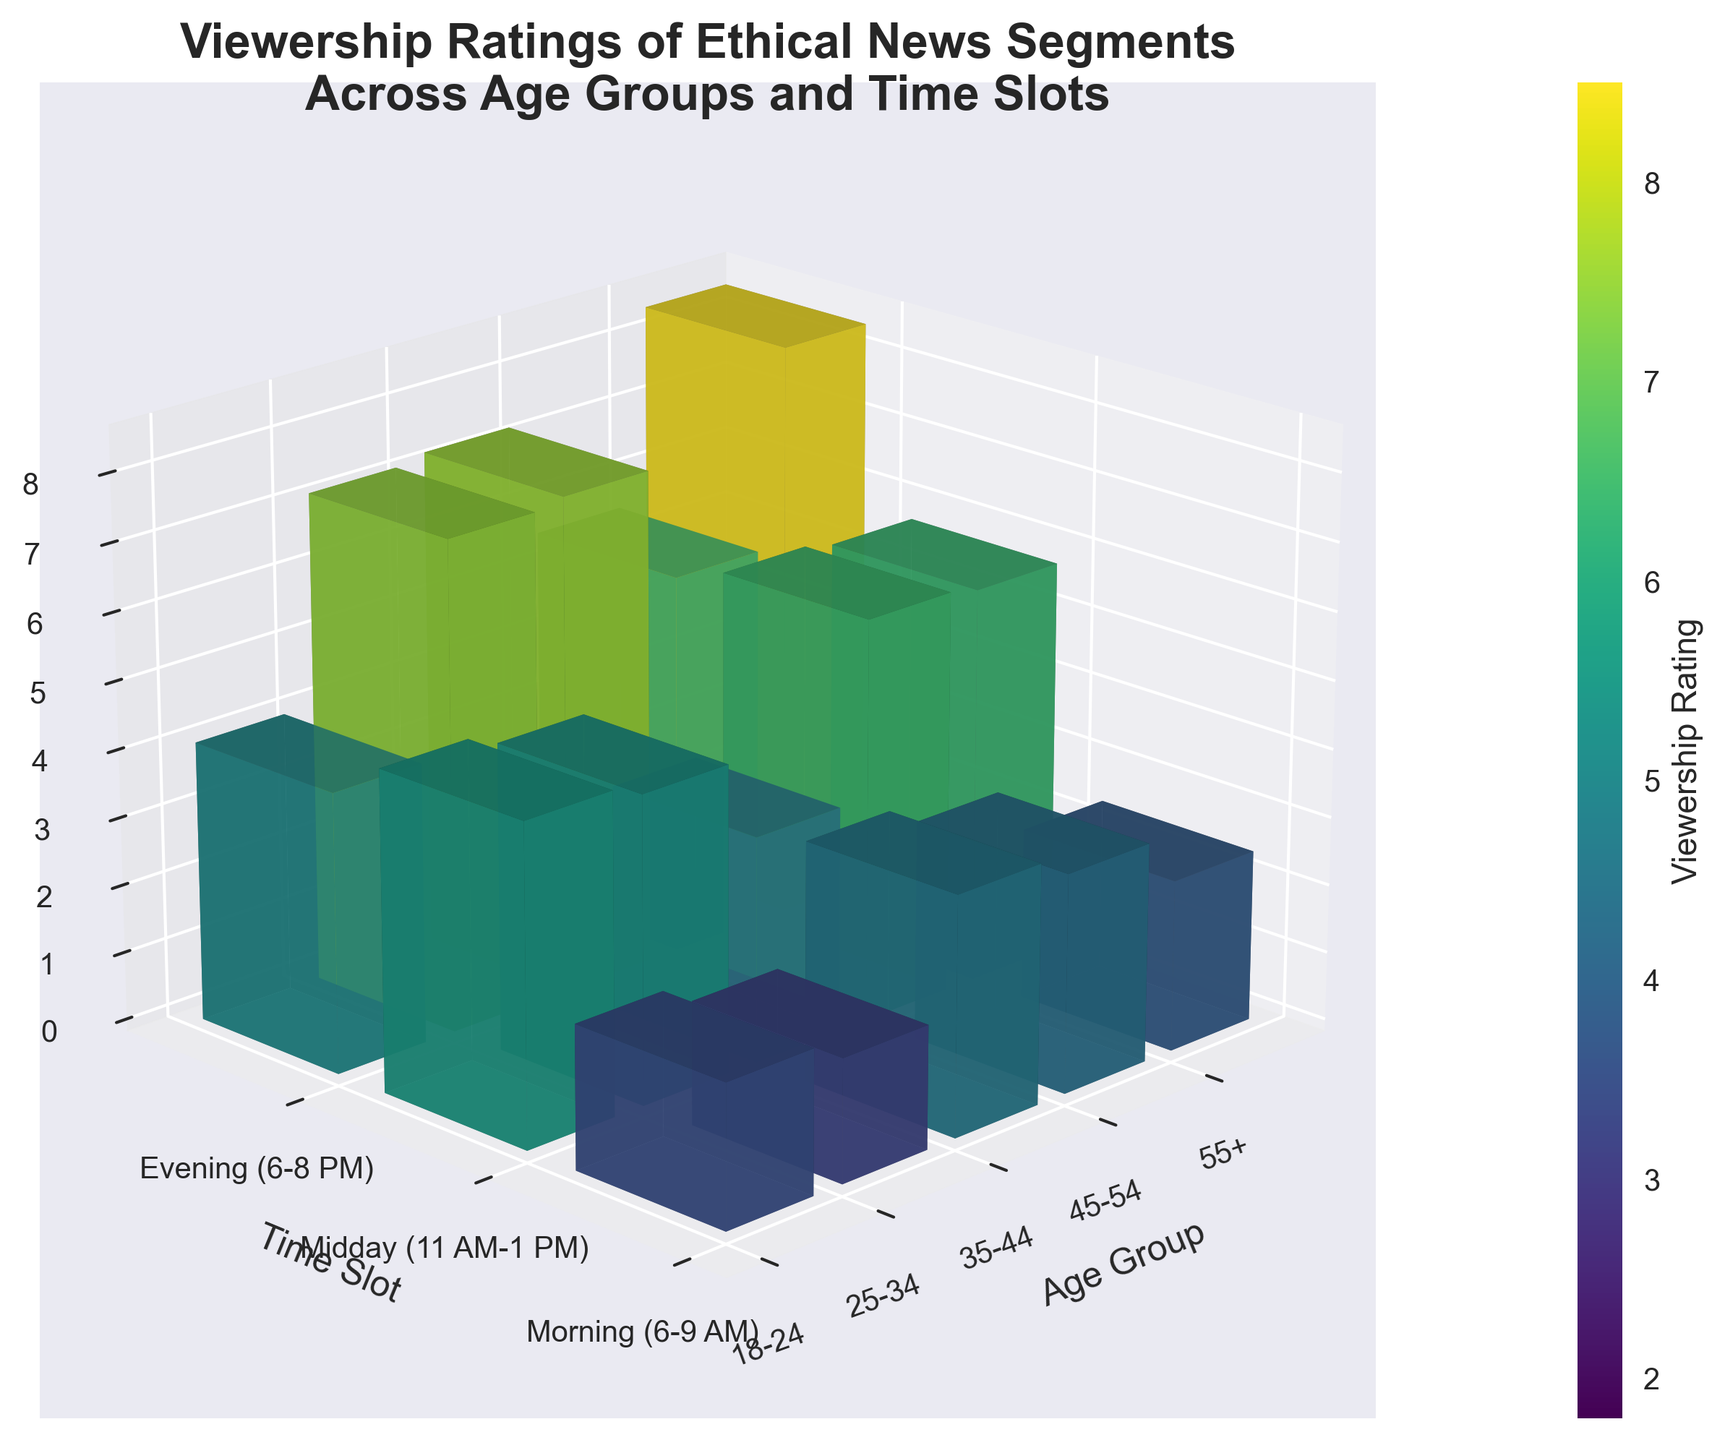What is the title of the figure? The title is usually located at the top of the chart. By examining that area, we can see the title given.
Answer: Viewership Ratings of Ethical News Segments Across Age Groups and Time Slots How many age groups are represented in the figure? Consider the number of unique labels on the x-axis, where the age groups are specified. Count these unique labels.
Answer: 5 Which age group has the highest evening viewership rating? Look at the evening time slot bars for each age group and identify the tallest bar. The tallest bar corresponds to the highest rating.
Answer: 55+ What is the viewership rating for the 18-24 age group in the morning time slot? Find the bar that corresponds to the 18-24 age group on the x-axis and the morning time slot on the y-axis, then read the height of the bar on the z-axis.
Answer: 2.1 In which time slot does the 45-54 age group have the highest viewership rating? Examine the bars for the 45-54 age group across all time slots and identify the one with the greatest height.
Answer: Evening (6-8 PM) How does the viewership rating trend change throughout the day for the 35-44 age group? Compare the heights of the bars for the 35-44 age group across all three time slots (morning, midday, evening) to see if the rating increases, decreases, or remains stable.
Answer: Increases from morning to evening What is the average viewership rating across all time slots for the 25-34 age group? Add the ratings for the 25-34 age group across all three time slots and divide by the number of time slots (3). Calculation: (3.2 + 2.5 + 4.7) / 3
Answer: 3.47 Which age group shows the largest difference in viewership ratings between the morning and evening time slots? Calculate the difference between the morning and evening ratings for each age group, then identify the largest difference.
Answer: 55+ (difference of 1.2) What is the color gradient used to represent the viewership ratings? The color gradient is indicated by the colorbar legend on the side of the chart. Observe the range of colors from low to high values.
Answer: Viridis How does the viewership rating of the 18-24 age group compare to the 55+ age group in the midday time slot? Compare the heights of the bars for the 18-24 and 55+ age groups in the midday time slot to determine which is higher.
Answer: 55+ is higher (5.6 vs 1.8) 